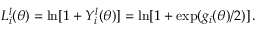Convert formula to latex. <formula><loc_0><loc_0><loc_500><loc_500>L _ { i } ^ { l } ( \theta ) = \ln [ 1 + Y _ { i } ^ { l } ( \theta ) ] = \ln [ 1 + \exp ( g _ { i } ( \theta ) / 2 ) ] \, .</formula> 